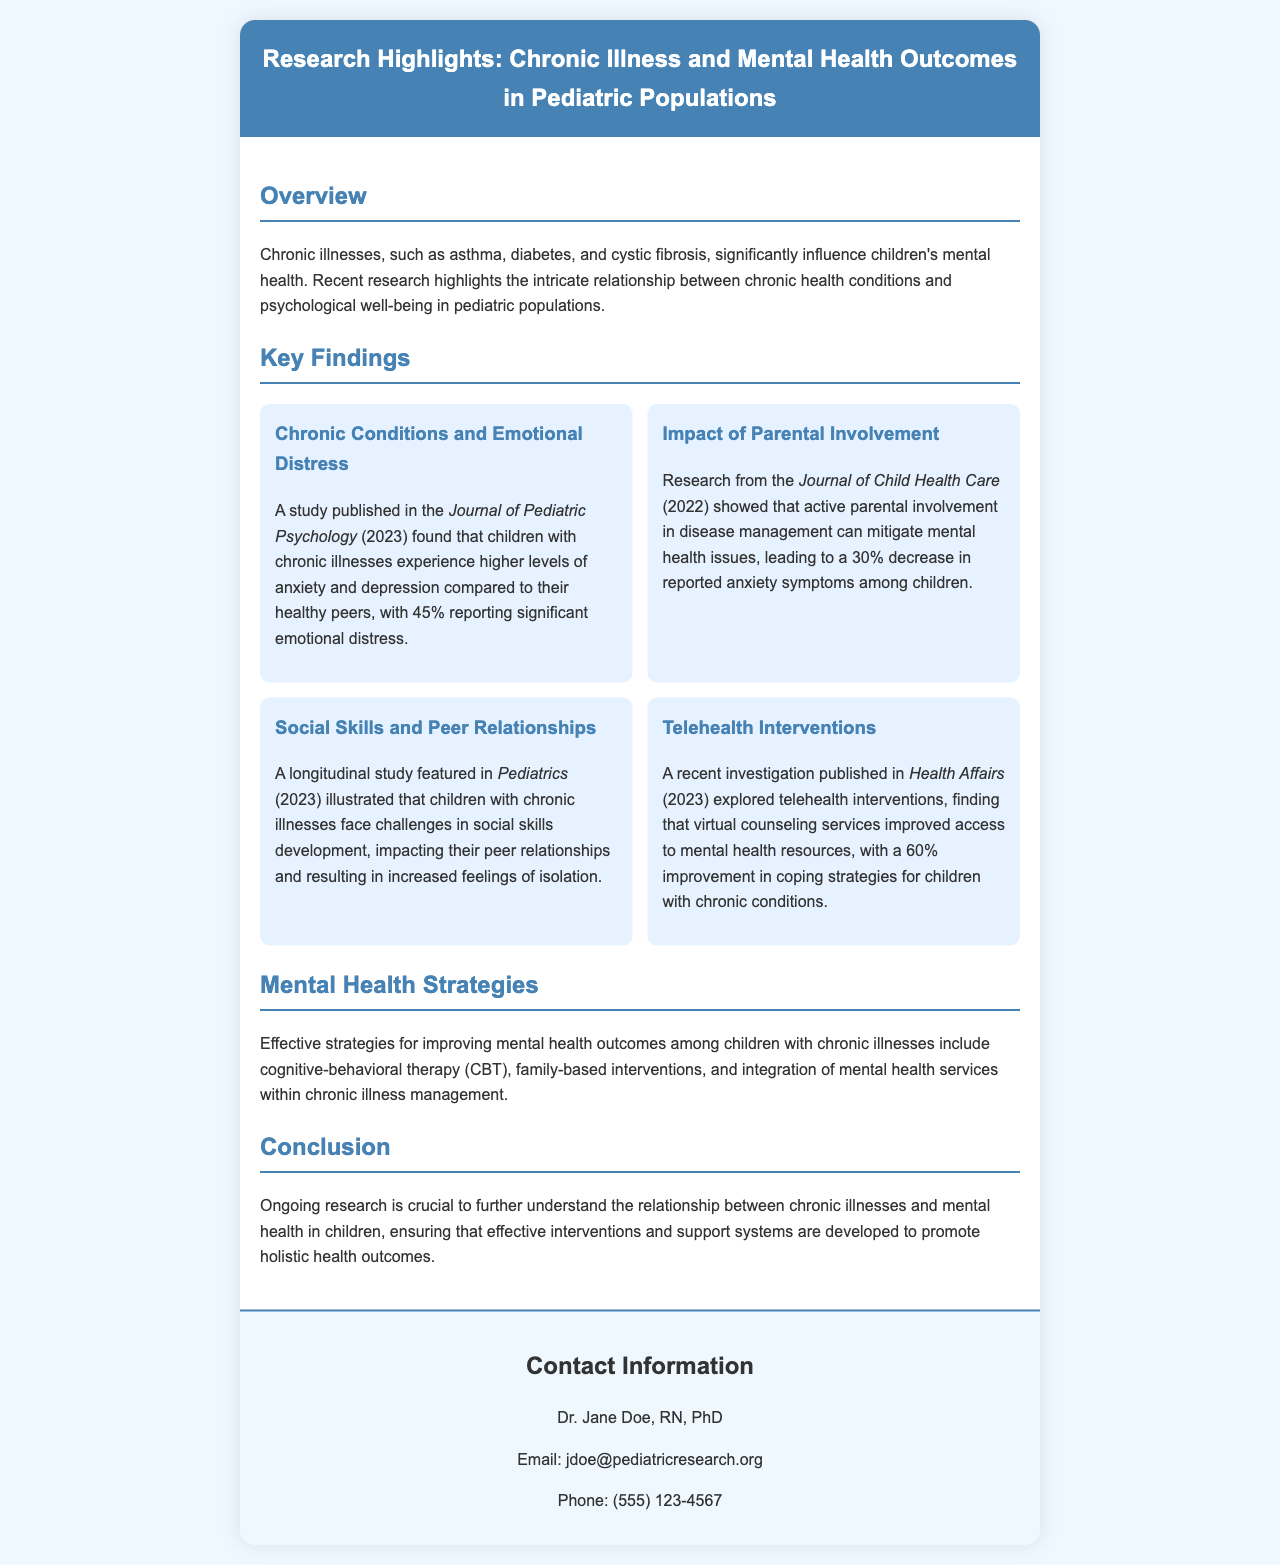What study found that 45% of children with chronic illnesses report emotional distress? The study published in the Journal of Pediatric Psychology (2023) found that 45% of children with chronic illnesses report significant emotional distress.
Answer: Journal of Pediatric Psychology What percentage decrease in anxiety symptoms was associated with parental involvement? Research from the Journal of Child Health Care (2022) indicated that active parental involvement in disease management leads to a 30% decrease in reported anxiety symptoms among children.
Answer: 30% Which chronic illness was not specified in the overview? The overview does not specify particular chronic illnesses outside of asthma, diabetes, and cystic fibrosis.
Answer: None specified What intervention improved access to mental health resources by 60%? The investigation published in Health Affairs (2023) found that virtual counseling services improved access to mental health resources, with a 60% improvement in coping strategies.
Answer: Virtual counseling services What mental health strategy involves integrating services with chronic illness management? The effective strategy mentioned includes the integration of mental health services within chronic illness management.
Answer: Integration of mental health services 